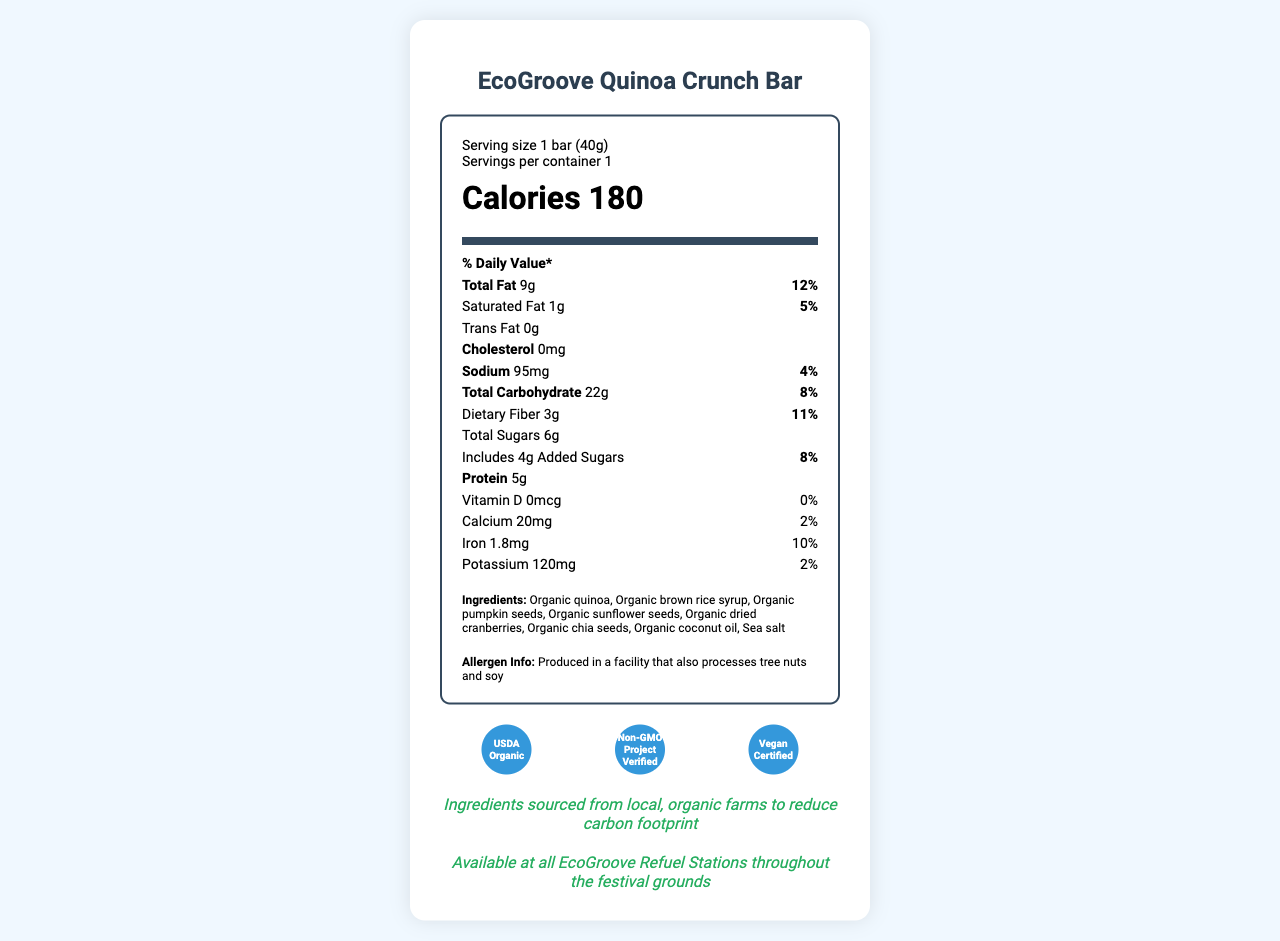what is the serving size of the EcoGroove Quinoa Crunch Bar? The serving size is explicitly stated as "1 bar (40g)" on the document.
Answer: 1 bar (40g) how many calories are in one serving of the EcoGroove Quinoa Crunch Bar? The document indicates that each serving contains 180 calories.
Answer: 180 calories how much protein does the EcoGroove Quinoa Crunch Bar provide per serving? The protein content per serving is listed as 5g.
Answer: 5g what is the percentage of daily value for total fat in one serving of the EcoGroove Quinoa Crunch Bar? The percentage of daily value for total fat is provided as "12%" in the document.
Answer: 12% how much dietary fiber is in one serving of the EcoGroove Quinoa Crunch Bar? The dietary fiber content per serving is listed as 3g.
Answer: 3g how much iron is in one serving of the EcoGroove Quinoa Crunch Bar? The iron content per serving is provided as 1.8mg.
Answer: 1.8mg does the EcoGroove Quinoa Crunch Bar contain any trans fat? The document notes that there is 0g trans fat per serving.
Answer: No which of the following certifications does the EcoGroove Quinoa Crunch Bar have? A. USDA Organic B. Gluten-Free Certified C. Vegan Certified D. Fair Trade Certified The certifications mentioned in the document are "USDA Organic," "Non-GMO Project Verified," and "Vegan Certified."
Answer: A, C how many grams of total sugars does the EcoGroove Quinoa Crunch Bar contain? The document lists the total sugar content as 6g per serving.
Answer: 6g which facility allergens are mentioned for the EcoGroove Quinoa Crunch Bar? A. Dairy B. Tree nuts C. Peanuts D. Soy The allergen information indicates that the product is produced in a facility that processes tree nuts and soy.
Answer: B, D is the wrapper of the EcoGroove Quinoa Crunch Bar compostable? The document states that the packaging is a "Compostable wrapper made from plant-based materials."
Answer: Yes does the EcoGroove Quinoa Crunch Bar contain any cholesterol? The document indicates that there is 0mg cholesterol in the product.
Answer: No describe the main idea of this document The document includes the nutritional composition of the product, including calories, fats, carbohydrates, protein, and vitamins/minerals per serving. Additionally, it mentions the organic ingredients used, allergen information, certifications, sustainability practices, and festival-specific availability.
Answer: The document provides detailed nutrition facts, ingredients, allergen information, and sustainability details for the "EcoGroove Quinoa Crunch Bar," highlighting its vegan certification and eco-friendly packaging suitable for a sustainable music festival. how much calcium does the EcoGroove Quinoa Crunch Bar provide per serving? The document specifies that each serving contains 20mg of calcium.
Answer: 20mg where can the EcoGroove Quinoa Crunch Bar be found at the festival? The document states that the bar is available at all EcoGroove Refuel Stations throughout the festival grounds.
Answer: EcoGroove Refuel Stations what is the total carbohydrate content of the EcoGroove Quinoa Crunch Bar per serving? The total carbohydrate content per serving is listed as 22g in the document.
Answer: 22g how much vitamin D does the EcoGroove Quinoa Crunch Bar provide? The document indicates that there is 0mcg of vitamin D in each serving.
Answer: 0mcg how much sodium is in one serving of the EcoGroove Quinoa Crunch Bar? The sodium content per serving is listed as 95mg.
Answer: 95mg is the EcoGroove Quinoa Crunch Bar certified as Non-GMO? The document mentions that the product is "Non-GMO Project Verified."
Answer: Yes what is the total fat content in one serving of the EcoGroove Quinoa Crunch Bar? The document specifies that the total fat content per serving is 9g.
Answer: 9g what is the origin of the ingredients used in the EcoGroove Quinoa Crunch Bar? The document mentions that the ingredients are sourced from local, organic farms, but it does not specify exactly where these farms are located.
Answer: Not enough information 